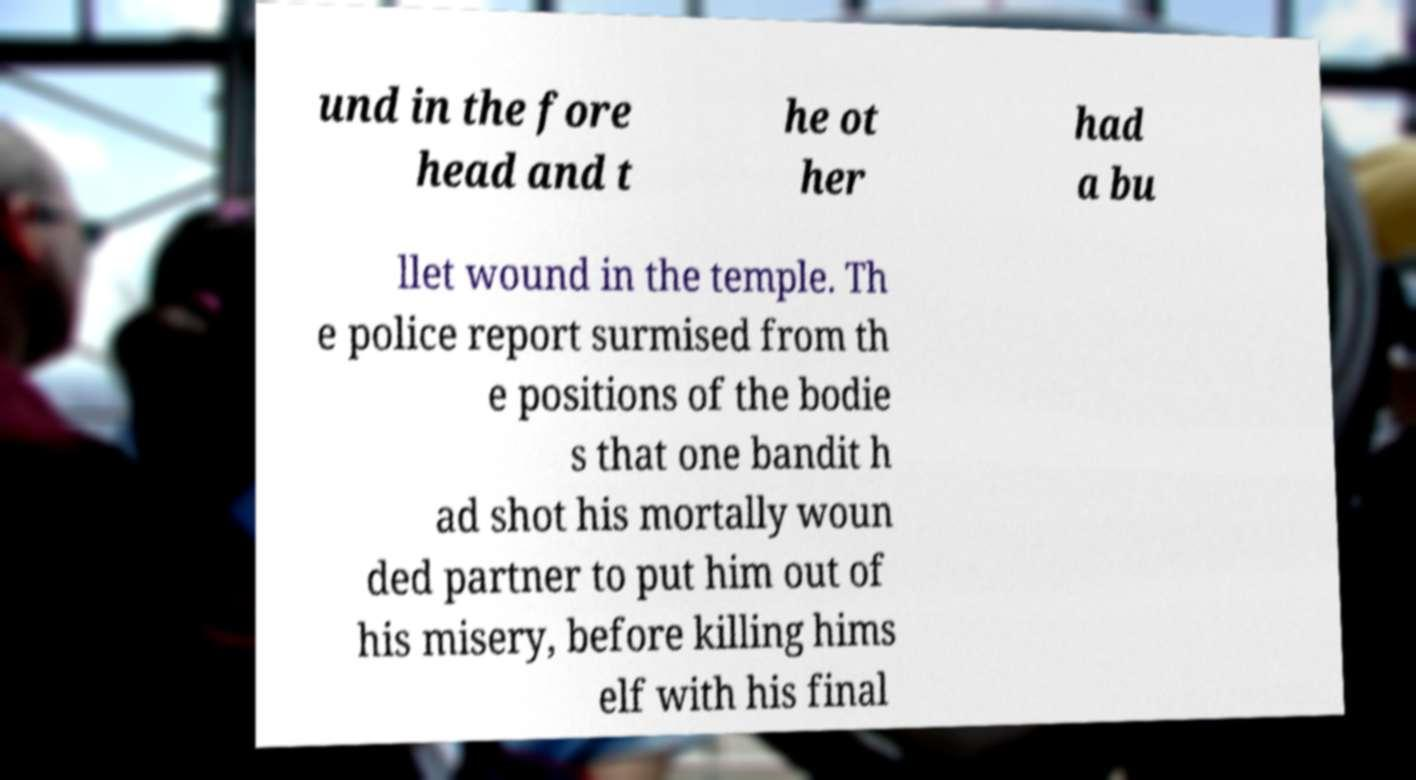Please read and relay the text visible in this image. What does it say? und in the fore head and t he ot her had a bu llet wound in the temple. Th e police report surmised from th e positions of the bodie s that one bandit h ad shot his mortally woun ded partner to put him out of his misery, before killing hims elf with his final 